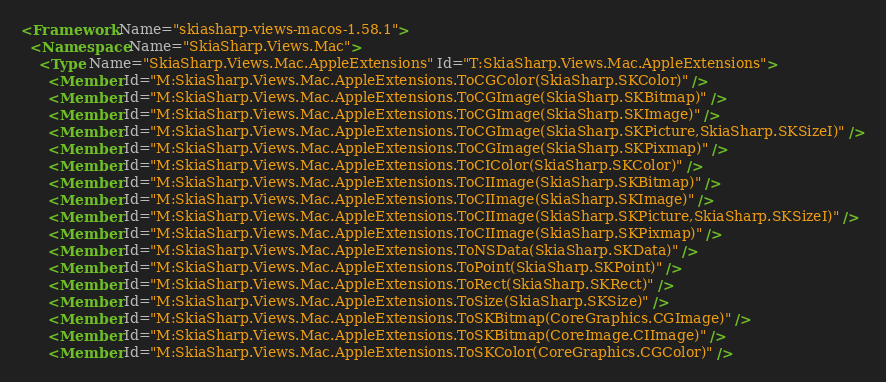<code> <loc_0><loc_0><loc_500><loc_500><_XML_><Framework Name="skiasharp-views-macos-1.58.1">
  <Namespace Name="SkiaSharp.Views.Mac">
    <Type Name="SkiaSharp.Views.Mac.AppleExtensions" Id="T:SkiaSharp.Views.Mac.AppleExtensions">
      <Member Id="M:SkiaSharp.Views.Mac.AppleExtensions.ToCGColor(SkiaSharp.SKColor)" />
      <Member Id="M:SkiaSharp.Views.Mac.AppleExtensions.ToCGImage(SkiaSharp.SKBitmap)" />
      <Member Id="M:SkiaSharp.Views.Mac.AppleExtensions.ToCGImage(SkiaSharp.SKImage)" />
      <Member Id="M:SkiaSharp.Views.Mac.AppleExtensions.ToCGImage(SkiaSharp.SKPicture,SkiaSharp.SKSizeI)" />
      <Member Id="M:SkiaSharp.Views.Mac.AppleExtensions.ToCGImage(SkiaSharp.SKPixmap)" />
      <Member Id="M:SkiaSharp.Views.Mac.AppleExtensions.ToCIColor(SkiaSharp.SKColor)" />
      <Member Id="M:SkiaSharp.Views.Mac.AppleExtensions.ToCIImage(SkiaSharp.SKBitmap)" />
      <Member Id="M:SkiaSharp.Views.Mac.AppleExtensions.ToCIImage(SkiaSharp.SKImage)" />
      <Member Id="M:SkiaSharp.Views.Mac.AppleExtensions.ToCIImage(SkiaSharp.SKPicture,SkiaSharp.SKSizeI)" />
      <Member Id="M:SkiaSharp.Views.Mac.AppleExtensions.ToCIImage(SkiaSharp.SKPixmap)" />
      <Member Id="M:SkiaSharp.Views.Mac.AppleExtensions.ToNSData(SkiaSharp.SKData)" />
      <Member Id="M:SkiaSharp.Views.Mac.AppleExtensions.ToPoint(SkiaSharp.SKPoint)" />
      <Member Id="M:SkiaSharp.Views.Mac.AppleExtensions.ToRect(SkiaSharp.SKRect)" />
      <Member Id="M:SkiaSharp.Views.Mac.AppleExtensions.ToSize(SkiaSharp.SKSize)" />
      <Member Id="M:SkiaSharp.Views.Mac.AppleExtensions.ToSKBitmap(CoreGraphics.CGImage)" />
      <Member Id="M:SkiaSharp.Views.Mac.AppleExtensions.ToSKBitmap(CoreImage.CIImage)" />
      <Member Id="M:SkiaSharp.Views.Mac.AppleExtensions.ToSKColor(CoreGraphics.CGColor)" /></code> 